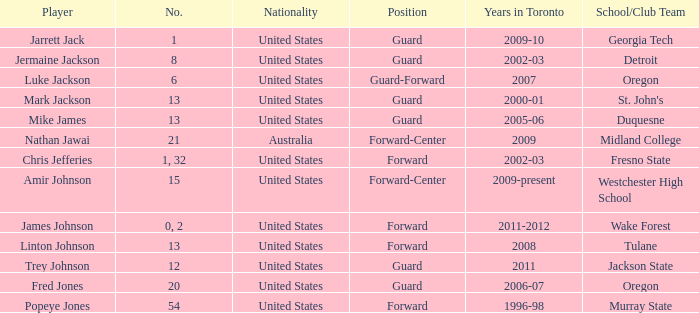What are the total number of positions on the Toronto team in 2006-07? 1.0. 